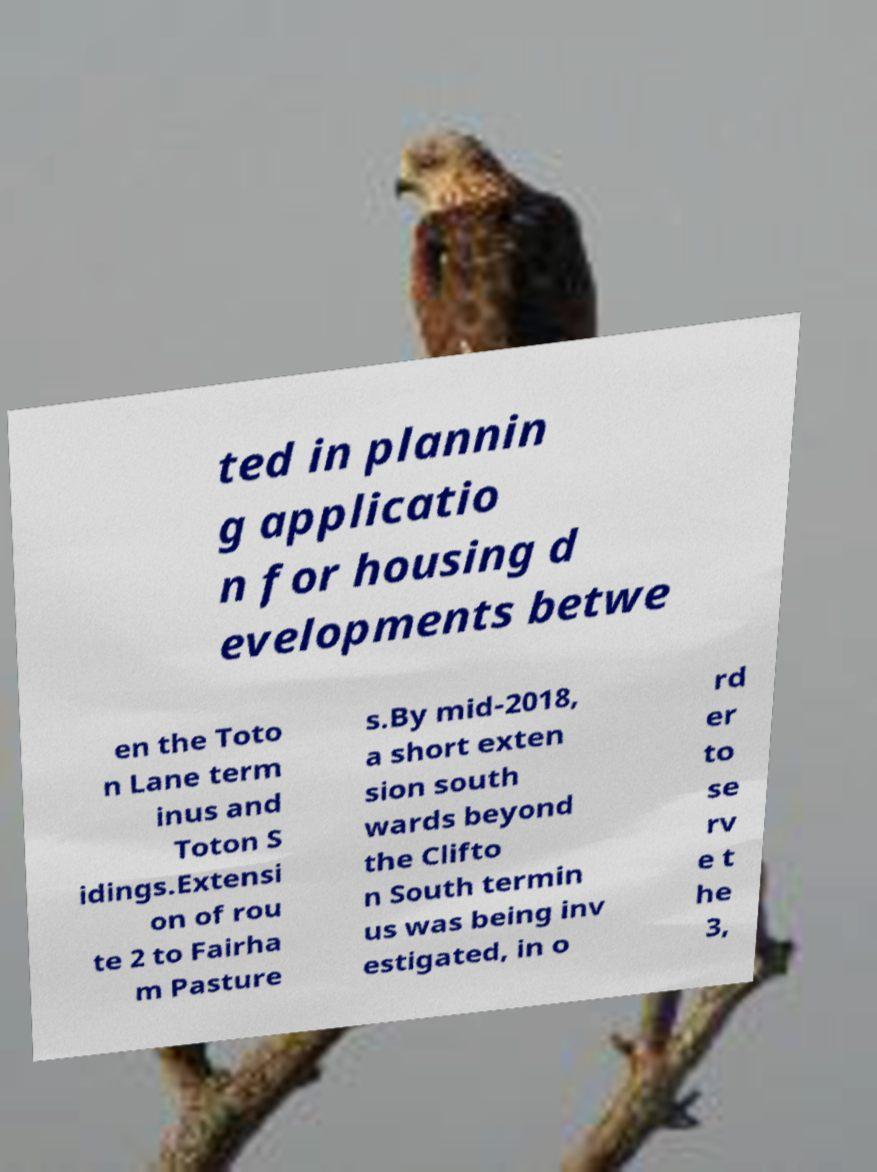Could you extract and type out the text from this image? ted in plannin g applicatio n for housing d evelopments betwe en the Toto n Lane term inus and Toton S idings.Extensi on of rou te 2 to Fairha m Pasture s.By mid-2018, a short exten sion south wards beyond the Clifto n South termin us was being inv estigated, in o rd er to se rv e t he 3, 